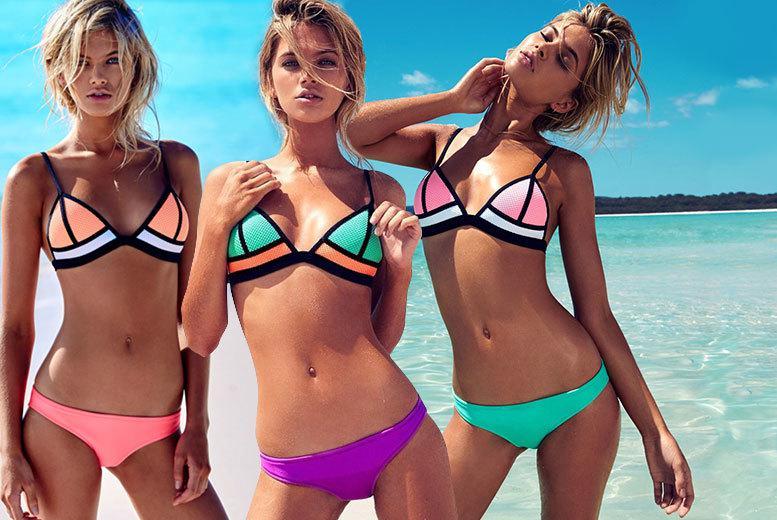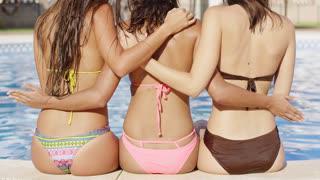The first image is the image on the left, the second image is the image on the right. Given the left and right images, does the statement "Three women are wearing bikinis in each of the images." hold true? Answer yes or no. Yes. The first image is the image on the left, the second image is the image on the right. Assess this claim about the two images: "At least one image depicts a trio of rear-facing arm-linked models in front of water.". Correct or not? Answer yes or no. Yes. 